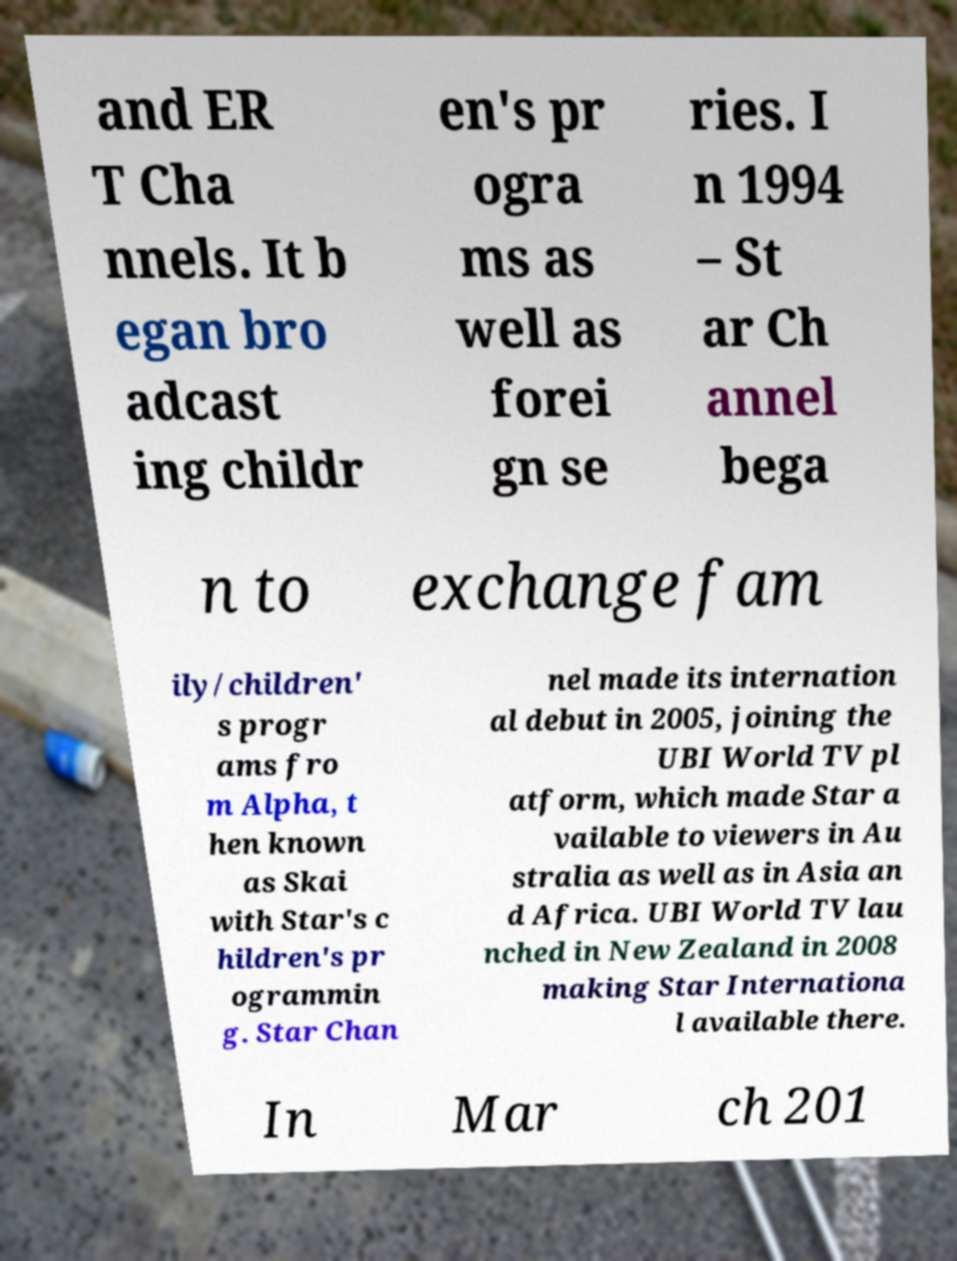What messages or text are displayed in this image? I need them in a readable, typed format. and ER T Cha nnels. It b egan bro adcast ing childr en's pr ogra ms as well as forei gn se ries. I n 1994 – St ar Ch annel bega n to exchange fam ily/children' s progr ams fro m Alpha, t hen known as Skai with Star's c hildren's pr ogrammin g. Star Chan nel made its internation al debut in 2005, joining the UBI World TV pl atform, which made Star a vailable to viewers in Au stralia as well as in Asia an d Africa. UBI World TV lau nched in New Zealand in 2008 making Star Internationa l available there. In Mar ch 201 